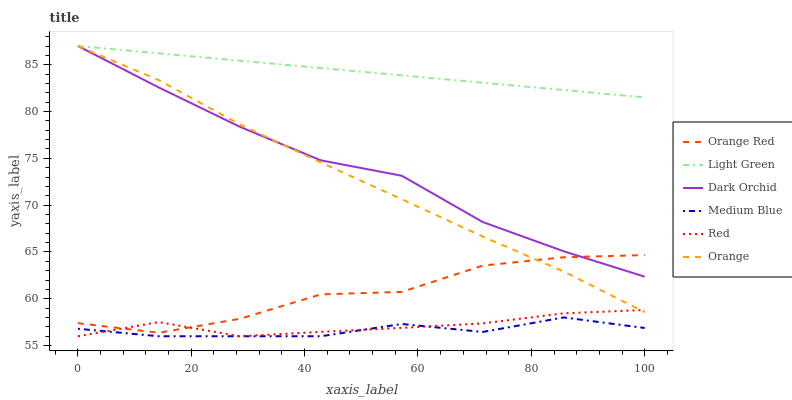Does Medium Blue have the minimum area under the curve?
Answer yes or no. Yes. Does Light Green have the maximum area under the curve?
Answer yes or no. Yes. Does Dark Orchid have the minimum area under the curve?
Answer yes or no. No. Does Dark Orchid have the maximum area under the curve?
Answer yes or no. No. Is Light Green the smoothest?
Answer yes or no. Yes. Is Orange Red the roughest?
Answer yes or no. Yes. Is Dark Orchid the smoothest?
Answer yes or no. No. Is Dark Orchid the roughest?
Answer yes or no. No. Does Medium Blue have the lowest value?
Answer yes or no. Yes. Does Dark Orchid have the lowest value?
Answer yes or no. No. Does Orange have the highest value?
Answer yes or no. Yes. Does Orange Red have the highest value?
Answer yes or no. No. Is Red less than Light Green?
Answer yes or no. Yes. Is Dark Orchid greater than Medium Blue?
Answer yes or no. Yes. Does Dark Orchid intersect Light Green?
Answer yes or no. Yes. Is Dark Orchid less than Light Green?
Answer yes or no. No. Is Dark Orchid greater than Light Green?
Answer yes or no. No. Does Red intersect Light Green?
Answer yes or no. No. 